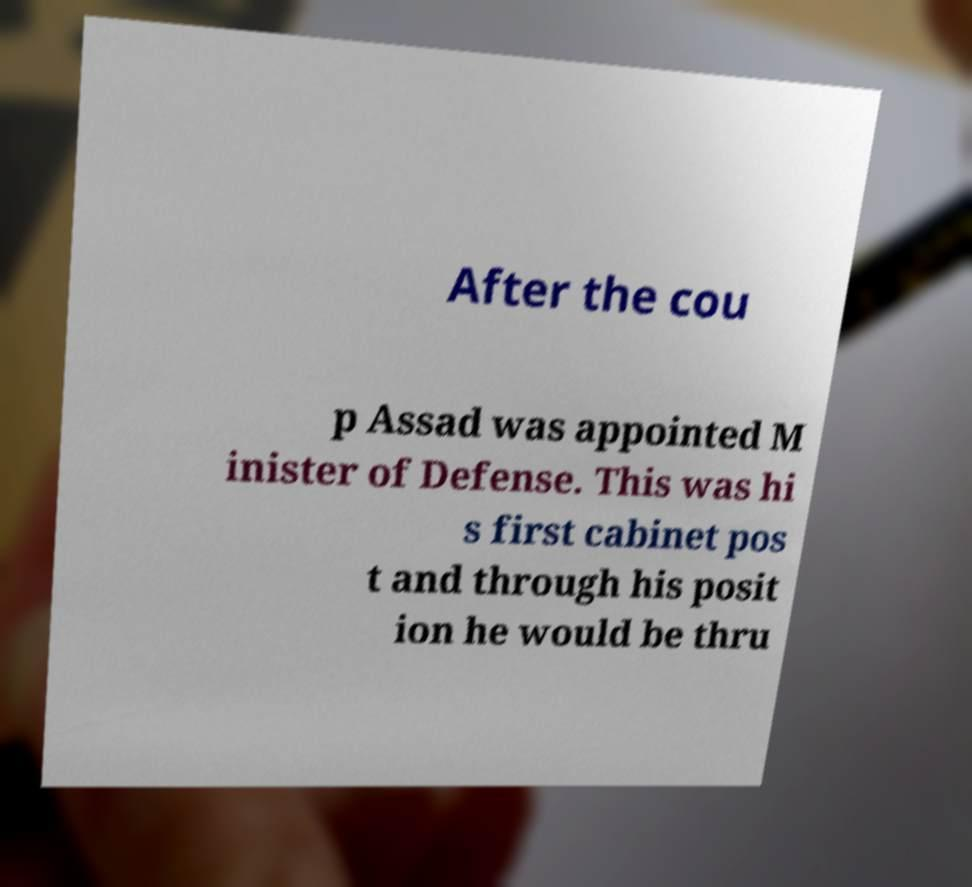For documentation purposes, I need the text within this image transcribed. Could you provide that? After the cou p Assad was appointed M inister of Defense. This was hi s first cabinet pos t and through his posit ion he would be thru 